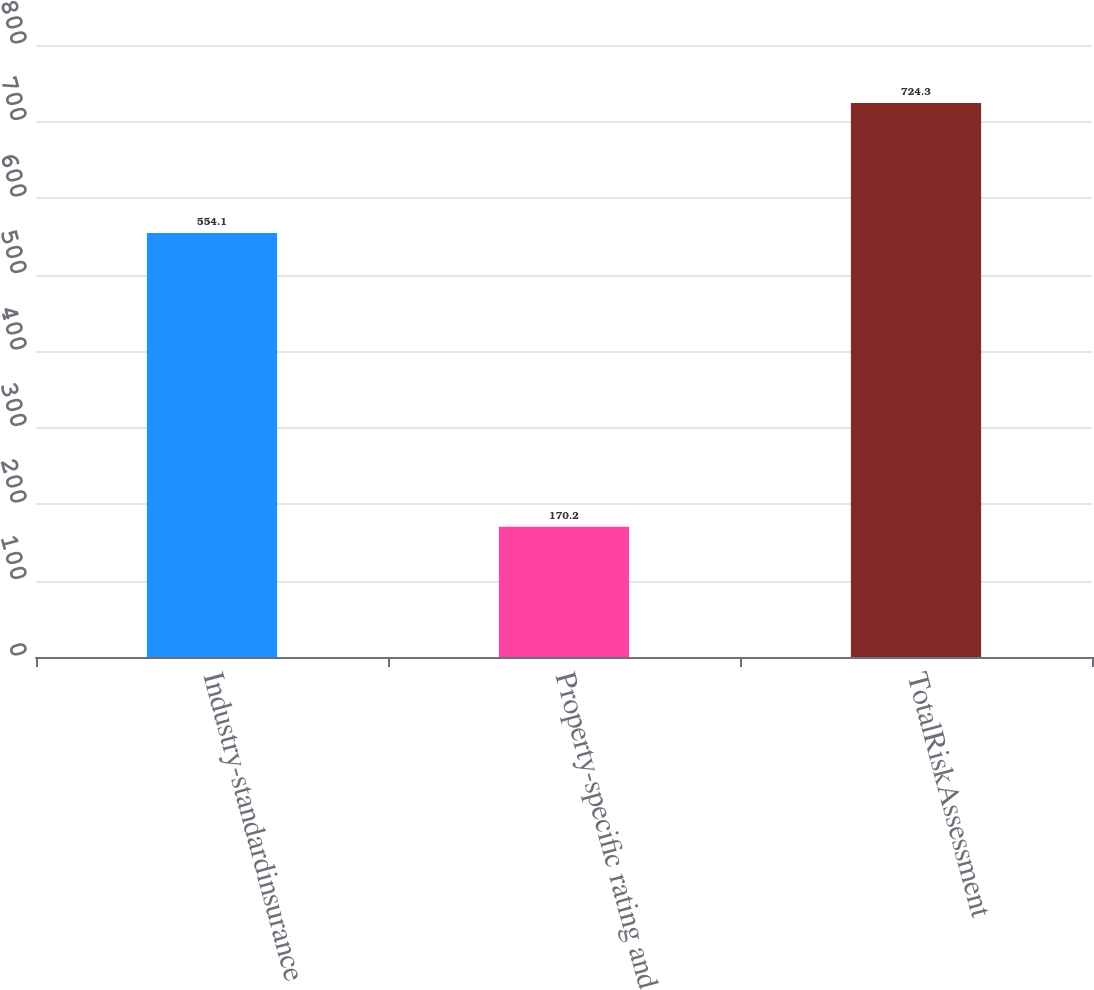Convert chart. <chart><loc_0><loc_0><loc_500><loc_500><bar_chart><fcel>Industry-standardinsurance<fcel>Property-specific rating and<fcel>TotalRiskAssessment<nl><fcel>554.1<fcel>170.2<fcel>724.3<nl></chart> 